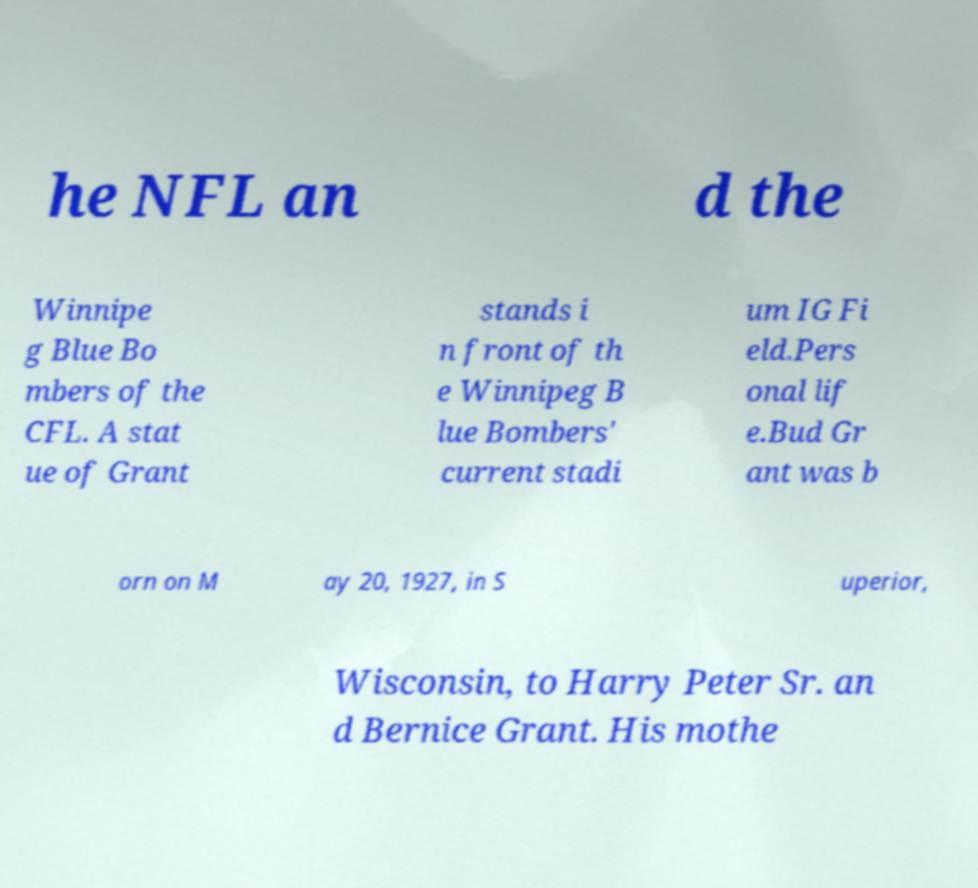For documentation purposes, I need the text within this image transcribed. Could you provide that? he NFL an d the Winnipe g Blue Bo mbers of the CFL. A stat ue of Grant stands i n front of th e Winnipeg B lue Bombers' current stadi um IG Fi eld.Pers onal lif e.Bud Gr ant was b orn on M ay 20, 1927, in S uperior, Wisconsin, to Harry Peter Sr. an d Bernice Grant. His mothe 